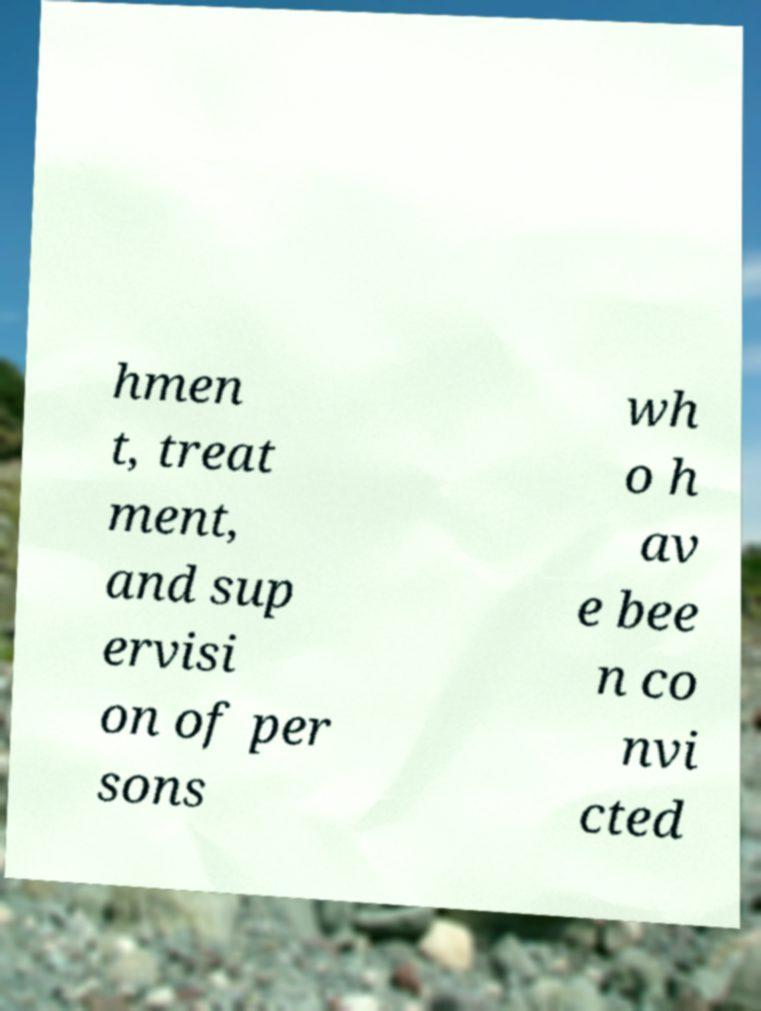Could you assist in decoding the text presented in this image and type it out clearly? hmen t, treat ment, and sup ervisi on of per sons wh o h av e bee n co nvi cted 